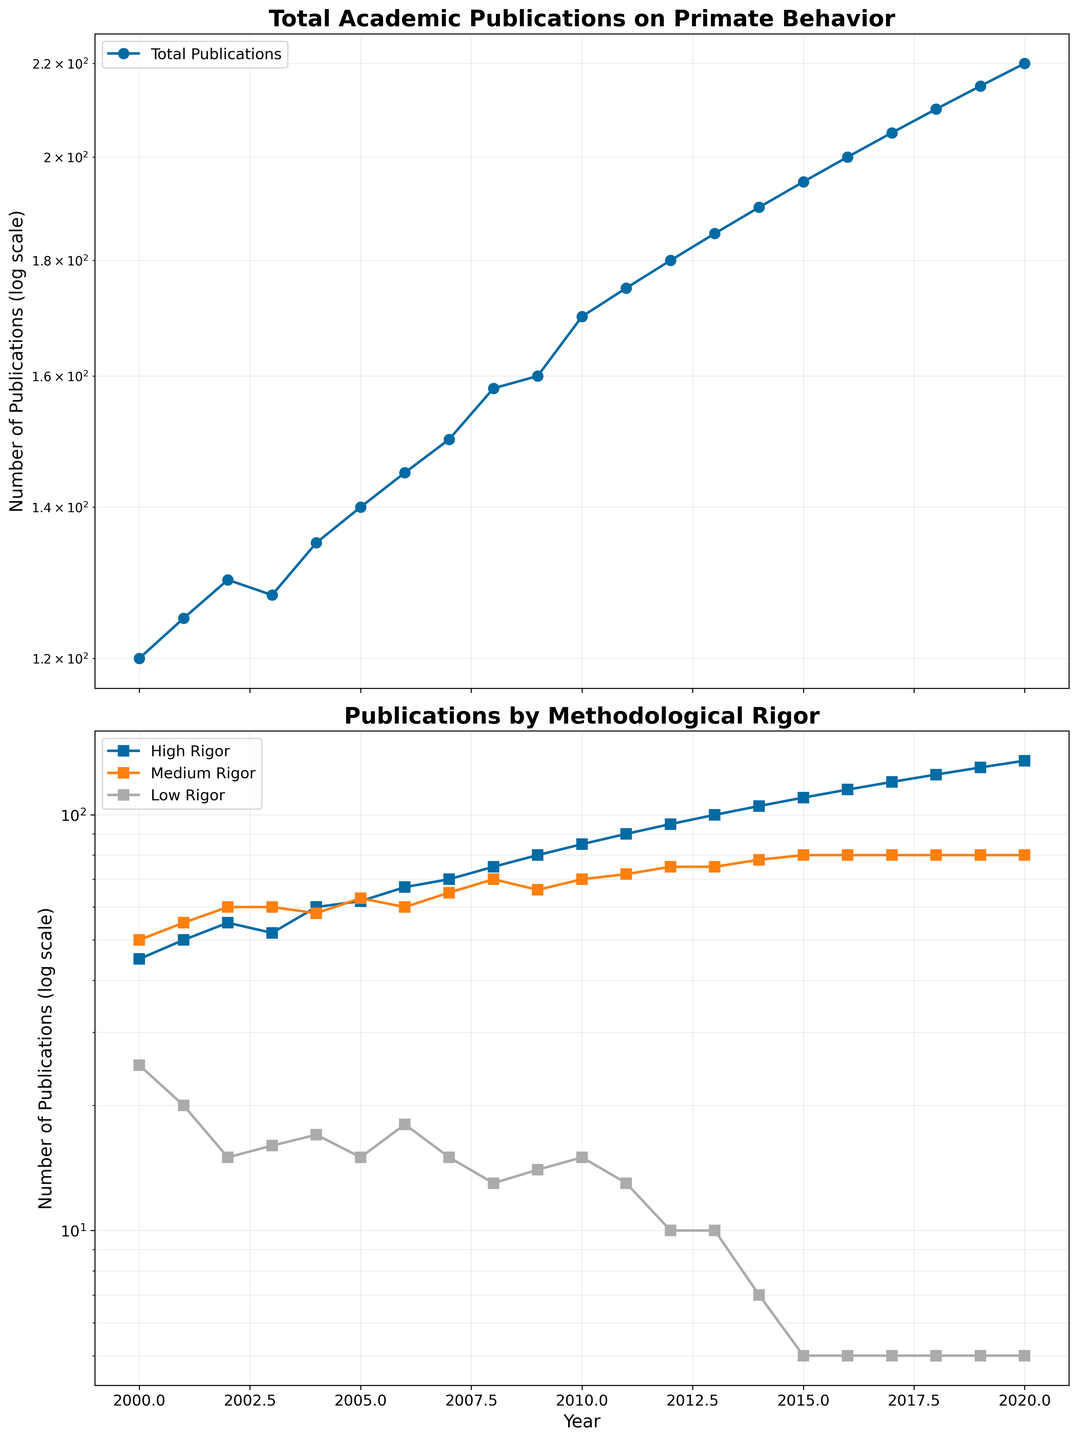What is the title of the first subplot? The title of the first subplot is located at the top of the subplot.
Answer: Total Academic Publications on Primate Behavior What is the y-axis scale used for the second subplot? The second subplot uses a logarithmic scale on the y-axis, indicated by the logarithmic labels on the axis.
Answer: Logarithmic scale How many total publications were there in 2018? To find the total publications in 2018, check the data point on the first subplot at the year 2018.
Answer: 210 Which category of rigor shows the highest number of publications in 2020? In the second subplot, identify the line corresponding to each rigor category at the year 2020, and compare the values.
Answer: High Rigor Compare the number of high-rigor publications in 2012 and 2020. How much did it increase? Subtract the number of high-rigor publications in 2012 from the number in 2020. According to the data, it's 135 (2020) - 95 (2012).
Answer: 40 In which year did the total number of publications first exceed 150? Observe the first subplot and find the year where the total publications curve crosses 150.
Answer: 2007 What are the colors used to represent the High Rigor, Medium Rigor, and Low Rigor categories in the second subplot? The legend in the second subplot indicates the colors used for each category of rigor.
Answer: High Rigor: Blue, Medium Rigor: Orange, Low Rigor: Green Which year had the smallest number of Low-Rigor publications? Examine the second subplot for the Minimum data point along the Low Rigor curve.
Answer: 2015 Based on the second subplot, did the number of medium-rigor publications ever surpass the number of high-rigor publications? Compare the Medium Rigor and High Rigor curves. High Rigor publications consistently exceed Medium Rigor throughout the period.
Answer: No What is the trend for Total Publications from 2000 to 2020? The first subplot shows a steady increase over time, reflecting an upward trend.
Answer: Upward trend 